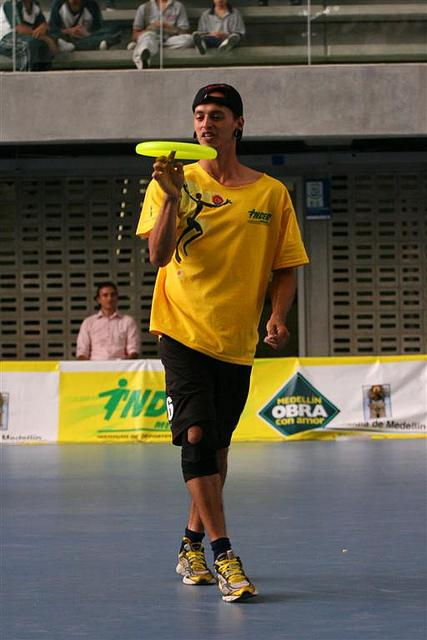The dominant color on the shirt is the same color as what food item? Please explain your reasoning. mustard. The dominant color is yellow and only one choice is yellow. the others food item choices are red, white, and green. 